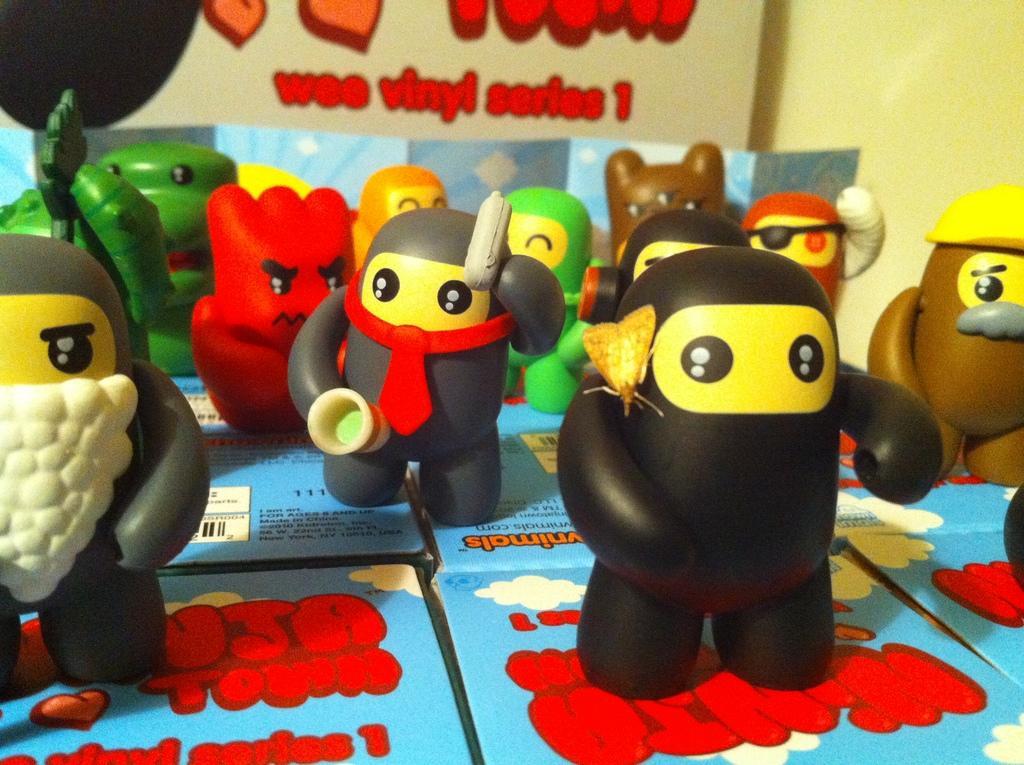Please provide a concise description of this image. In this image there are boxes on the bottom. There are colorful baby toys. There is a wall with some text. 